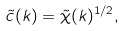<formula> <loc_0><loc_0><loc_500><loc_500>\tilde { c } ( k ) = \tilde { \chi } ( k ) ^ { 1 / 2 } ,</formula> 